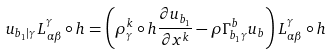<formula> <loc_0><loc_0><loc_500><loc_500>u _ { b _ { 1 } | \gamma } L _ { \alpha \beta } ^ { \gamma } \circ h = \left ( \rho _ { \gamma } ^ { k } \circ h \frac { \partial u _ { b _ { 1 } } } { \partial x ^ { k } } - \rho \Gamma _ { b _ { 1 } \gamma } ^ { b } u _ { b } \right ) L _ { \alpha \beta } ^ { \gamma } \circ h</formula> 